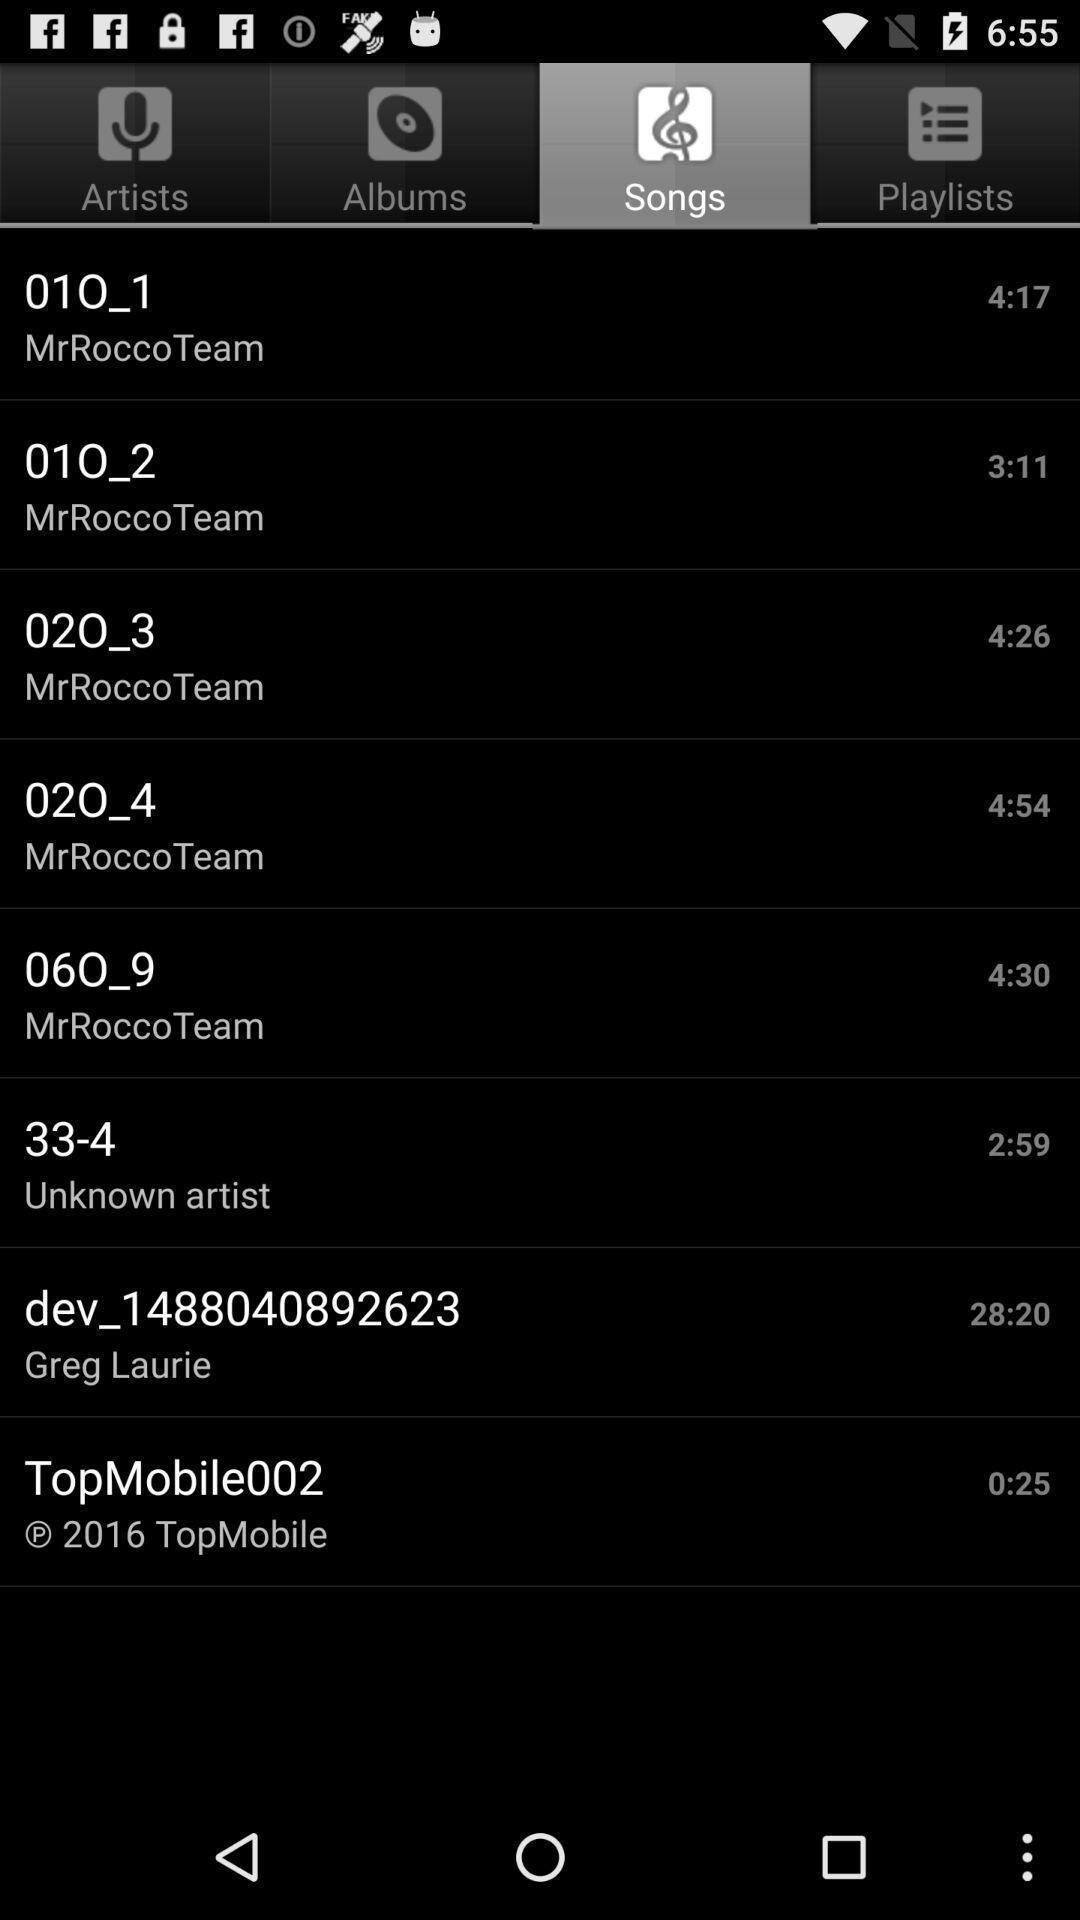Describe the visual elements of this screenshot. Page showing different songs available. 